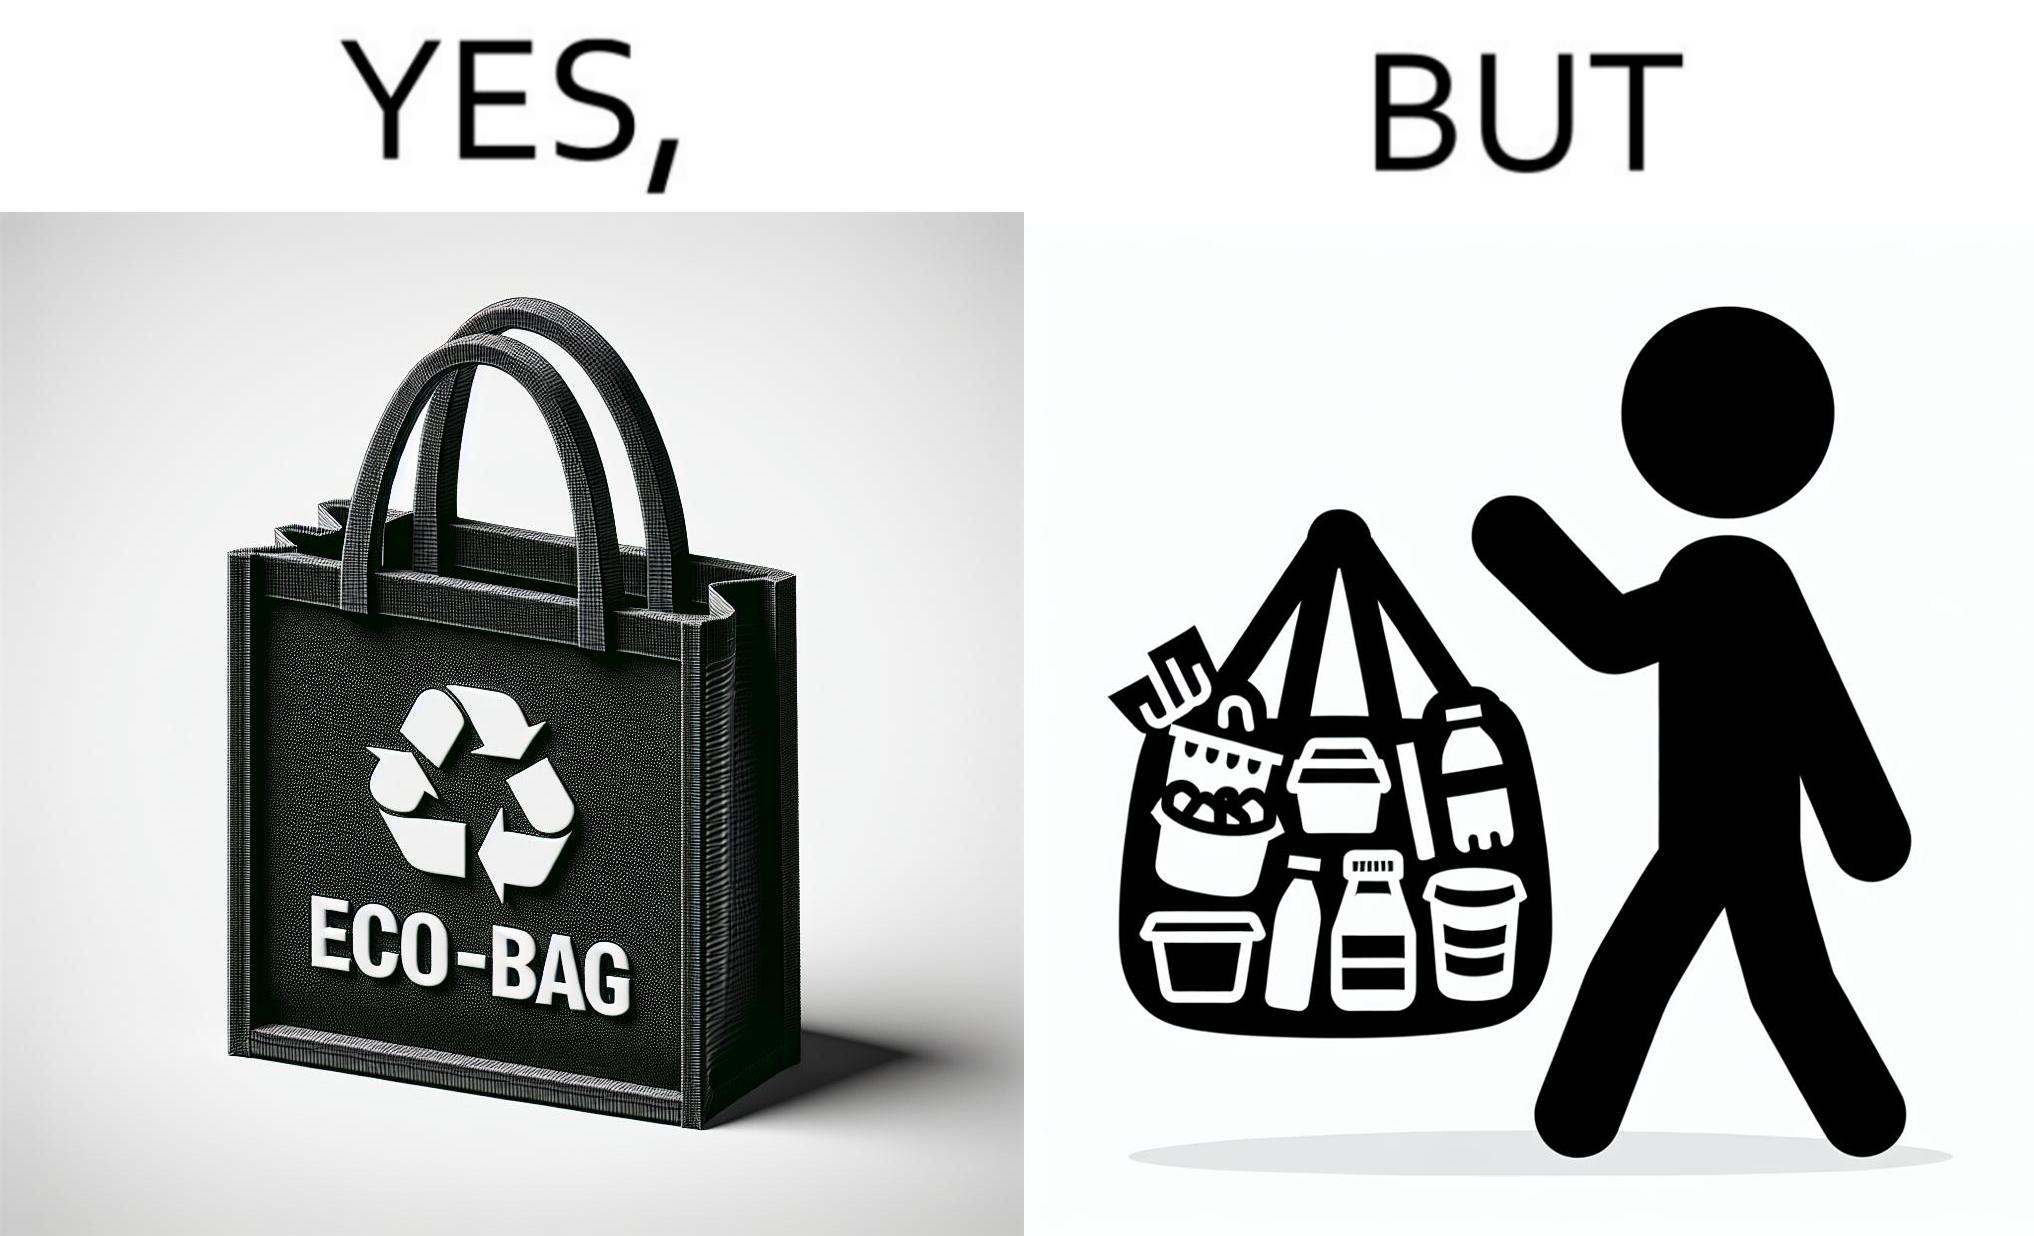Is this image satirical or non-satirical? Yes, this image is satirical. 